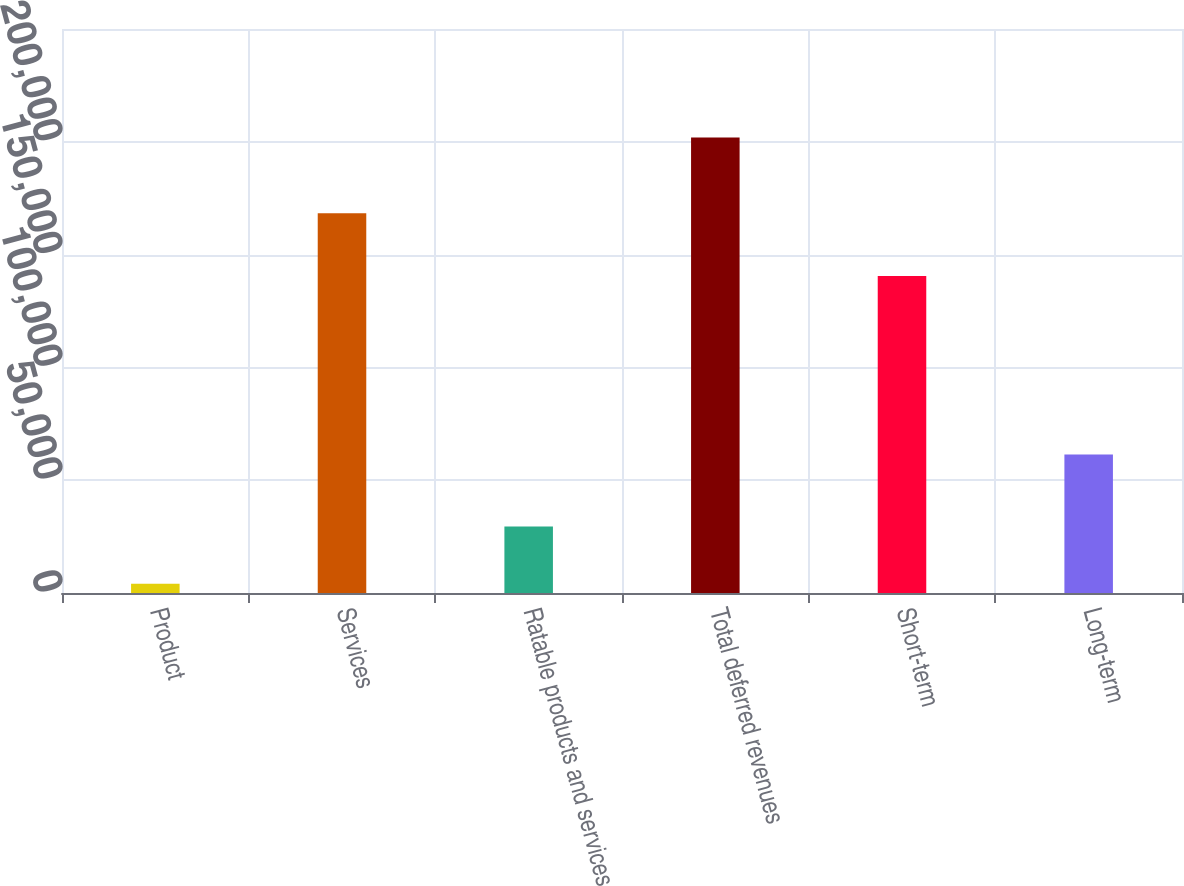Convert chart. <chart><loc_0><loc_0><loc_500><loc_500><bar_chart><fcel>Product<fcel>Services<fcel>Ratable products and services<fcel>Total deferred revenues<fcel>Short-term<fcel>Long-term<nl><fcel>4141<fcel>168314<fcel>29475<fcel>201930<fcel>140537<fcel>61393<nl></chart> 